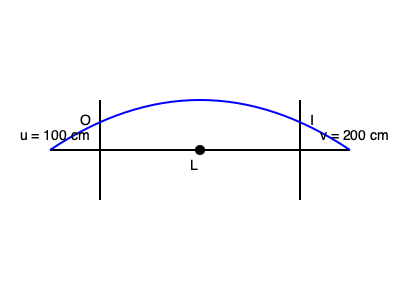As a photographer setting up your studio in the garage gallery, you're experimenting with different lenses. You place an object 100 cm in front of a convex lens and observe that a sharp image forms 200 cm behind the lens. Using the thin lens equation, calculate the focal length of this lens. To solve this problem, we'll use the thin lens equation:

$$\frac{1}{f} = \frac{1}{u} + \frac{1}{v}$$

Where:
$f$ = focal length (unknown)
$u$ = object distance = 100 cm
$v$ = image distance = 200 cm

Steps:
1) Substitute the known values into the equation:
   $$\frac{1}{f} = \frac{1}{100} + \frac{1}{200}$$

2) Find a common denominator on the right side:
   $$\frac{1}{f} = \frac{2}{200} + \frac{1}{200} = \frac{3}{200}$$

3) Now we have:
   $$\frac{1}{f} = \frac{3}{200}$$

4) To solve for $f$, take the reciprocal of both sides:
   $$f = \frac{200}{3}$$

5) Simplify:
   $$f = 66.67 \text{ cm}$$

Therefore, the focal length of the lens is approximately 66.67 cm.
Answer: $66.67 \text{ cm}$ 